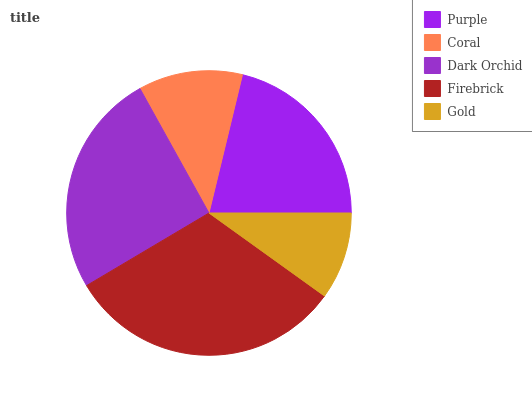Is Gold the minimum?
Answer yes or no. Yes. Is Firebrick the maximum?
Answer yes or no. Yes. Is Coral the minimum?
Answer yes or no. No. Is Coral the maximum?
Answer yes or no. No. Is Purple greater than Coral?
Answer yes or no. Yes. Is Coral less than Purple?
Answer yes or no. Yes. Is Coral greater than Purple?
Answer yes or no. No. Is Purple less than Coral?
Answer yes or no. No. Is Purple the high median?
Answer yes or no. Yes. Is Purple the low median?
Answer yes or no. Yes. Is Firebrick the high median?
Answer yes or no. No. Is Dark Orchid the low median?
Answer yes or no. No. 